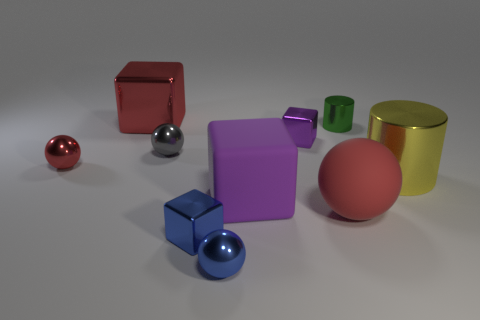Is the material of the small green cylinder the same as the small red thing?
Give a very brief answer. Yes. There is a blue metallic block; how many metal things are left of it?
Your response must be concise. 3. There is a red object that is both in front of the small green metal thing and on the left side of the big ball; what material is it?
Your answer should be compact. Metal. How many purple metal things have the same size as the blue block?
Keep it short and to the point. 1. What is the color of the cylinder that is in front of the shiny ball that is on the left side of the small gray ball?
Give a very brief answer. Yellow. Are there any cyan rubber cylinders?
Offer a terse response. No. Is the shape of the tiny green object the same as the yellow shiny thing?
Offer a very short reply. Yes. The other ball that is the same color as the rubber ball is what size?
Give a very brief answer. Small. There is a tiny metal cube in front of the gray ball; what number of red spheres are on the right side of it?
Make the answer very short. 1. How many big metallic things are both to the left of the tiny green object and in front of the gray object?
Provide a short and direct response. 0. 